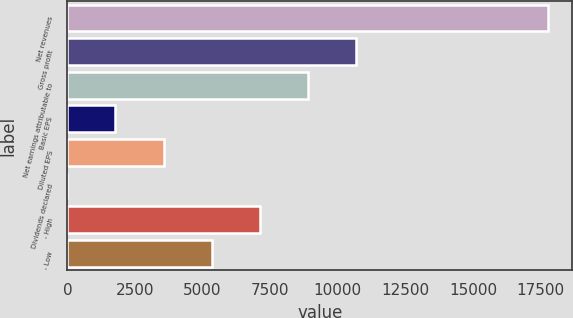<chart> <loc_0><loc_0><loc_500><loc_500><bar_chart><fcel>Net revenues<fcel>Gross profit<fcel>Net earnings attributable to<fcel>Basic EPS<fcel>Diluted EPS<fcel>Dividends declared<fcel>- High<fcel>- Low<nl><fcel>17779<fcel>10667.8<fcel>8889.99<fcel>1778.75<fcel>3556.56<fcel>0.94<fcel>7112.18<fcel>5334.37<nl></chart> 